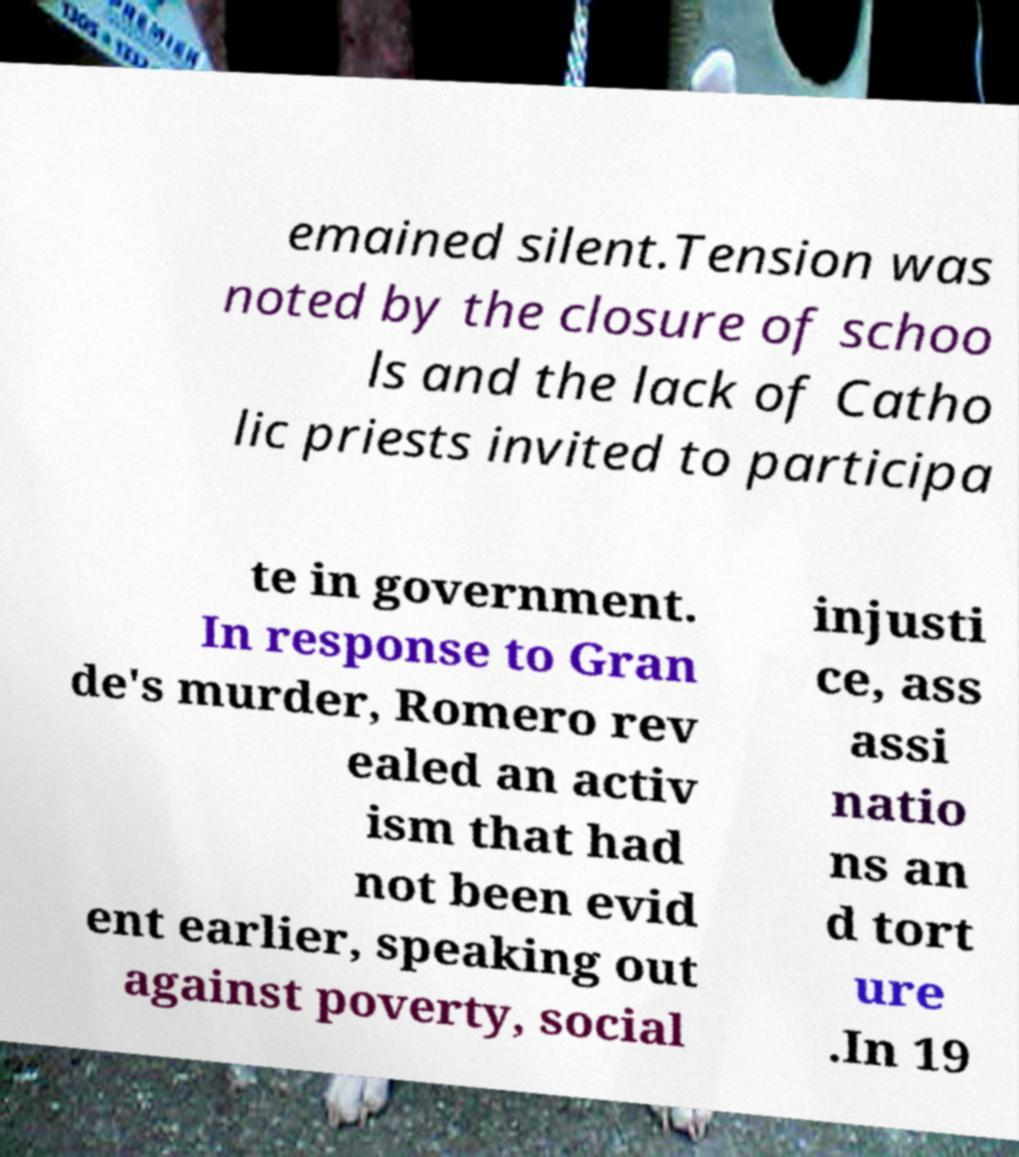Please read and relay the text visible in this image. What does it say? emained silent.Tension was noted by the closure of schoo ls and the lack of Catho lic priests invited to participa te in government. In response to Gran de's murder, Romero rev ealed an activ ism that had not been evid ent earlier, speaking out against poverty, social injusti ce, ass assi natio ns an d tort ure .In 19 